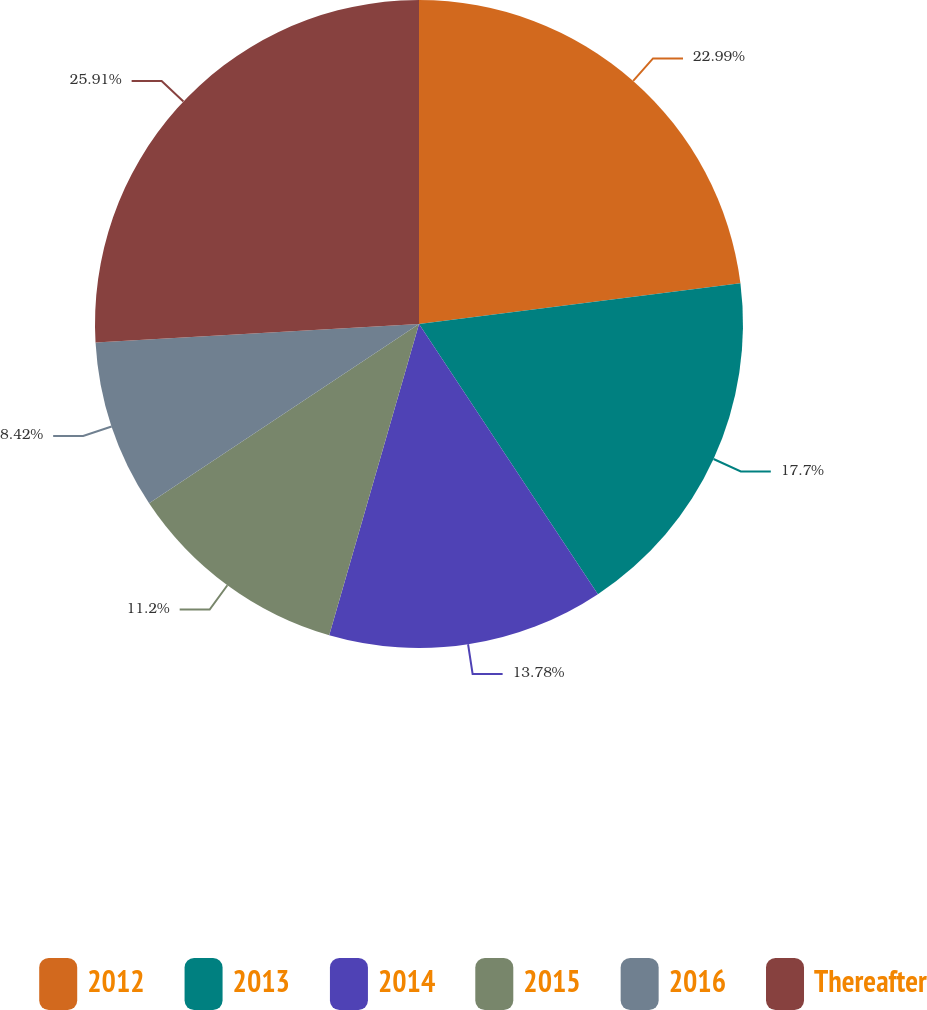Convert chart. <chart><loc_0><loc_0><loc_500><loc_500><pie_chart><fcel>2012<fcel>2013<fcel>2014<fcel>2015<fcel>2016<fcel>Thereafter<nl><fcel>22.99%<fcel>17.7%<fcel>13.78%<fcel>11.2%<fcel>8.42%<fcel>25.91%<nl></chart> 